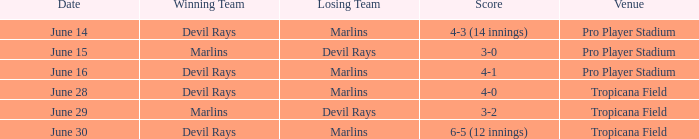What was the score on june 16? 4-1. 